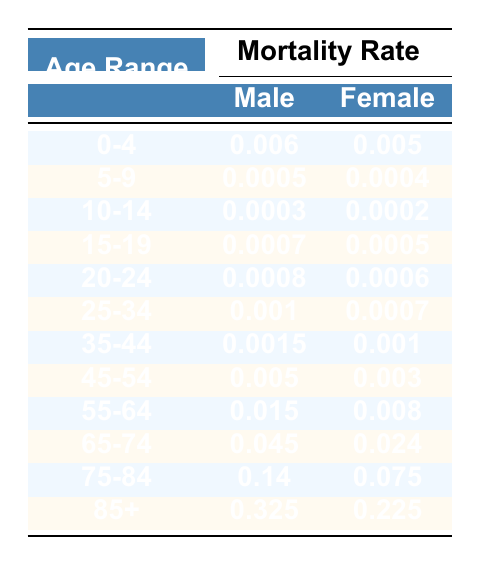What is the male mortality rate for the age group 55-64? The table shows that the male mortality rate for the age group 55-64 is listed directly across from the age range. It is 0.015.
Answer: 0.015 What is the difference in mortality rates between males and females for the age group 45-54? To find the difference, we subtract the female mortality rate (0.003) from the male mortality rate (0.005). Therefore, 0.005 - 0.003 = 0.002.
Answer: 0.002 Is the female mortality rate higher at age 75-84 than at age 65-74? The table states that the female mortality rate for age 75-84 is 0.075 and for age 65-74 is 0.024. Since 0.075 is greater than 0.024, the statement is true.
Answer: Yes What is the average male mortality rate across all age groups? To find the average, we first list the male mortality rates: 0.006, 0.0005, 0.0003, 0.0007, 0.0008, 0.001, 0.0015, 0.005, 0.015, 0.045, 0.14, 0.325. Summing these gives a total of 0.4758. There are 12 age groups, so we divide 0.4758 by 12, yielding an average of approximately 0.03965.
Answer: 0.03965 What is the female mortality rate for the age group 85+? Referring to the table, the female mortality rate for the age group 85+ is mentioned directly. It is 0.225.
Answer: 0.225 For which age group is the male mortality rate the highest? The table shows various age groups, and we need to identify the one with the highest male mortality rate. The highest is 0.325 for the age group 85+.
Answer: 85+ What percentage increase in male mortality rate is seen when comparing the age groups 0-4 and 75-84? First, we need to find the rates: male mortality rate for 0-4 is 0.006 and for 75-84 it is 0.14. The percentage increase can be found using the formula: [(0.14 - 0.006) / 0.006] * 100. This results in about 2166.67%.
Answer: 2166.67% Is the male mortality rate generally higher than the female mortality rate for the age group 25-34? For the age group 25-34, the male mortality rate is 0.001 and the female rate is 0.0007. Since 0.001 is greater than 0.0007, the answer is true.
Answer: Yes 